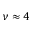Convert formula to latex. <formula><loc_0><loc_0><loc_500><loc_500>\nu \approx 4</formula> 